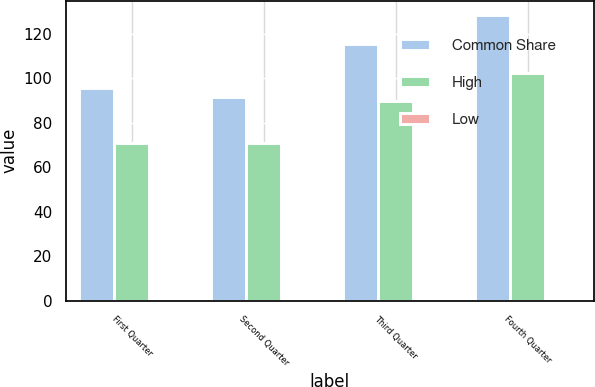Convert chart. <chart><loc_0><loc_0><loc_500><loc_500><stacked_bar_chart><ecel><fcel>First Quarter<fcel>Second Quarter<fcel>Third Quarter<fcel>Fourth Quarter<nl><fcel>Common Share<fcel>95.59<fcel>91.76<fcel>115.45<fcel>128.56<nl><fcel>High<fcel>71.14<fcel>71.12<fcel>89.66<fcel>102.33<nl><fcel>Low<fcel>0.1<fcel>0.1<fcel>0.1<fcel>0.2<nl></chart> 